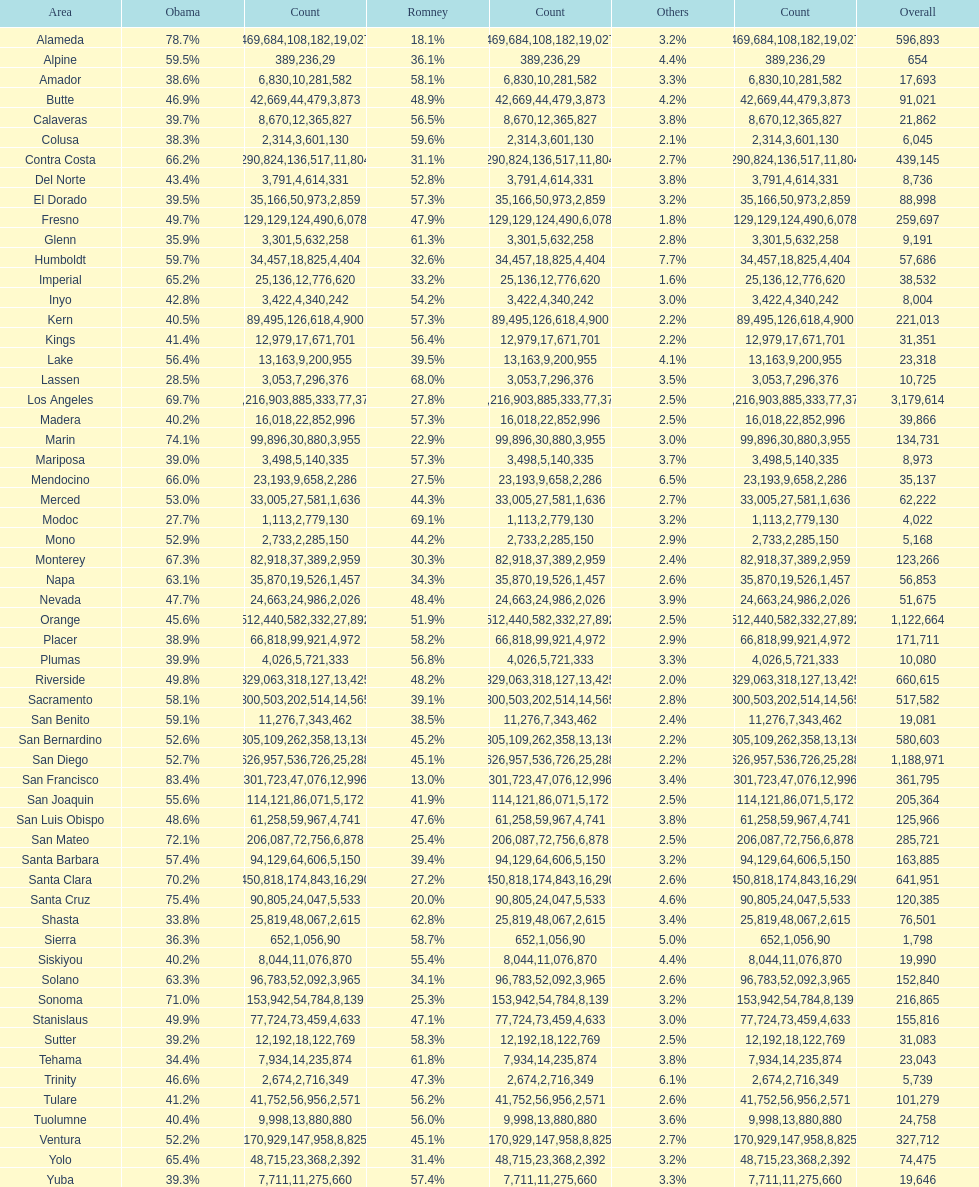Which count had the least number of votes for obama? Modoc. 